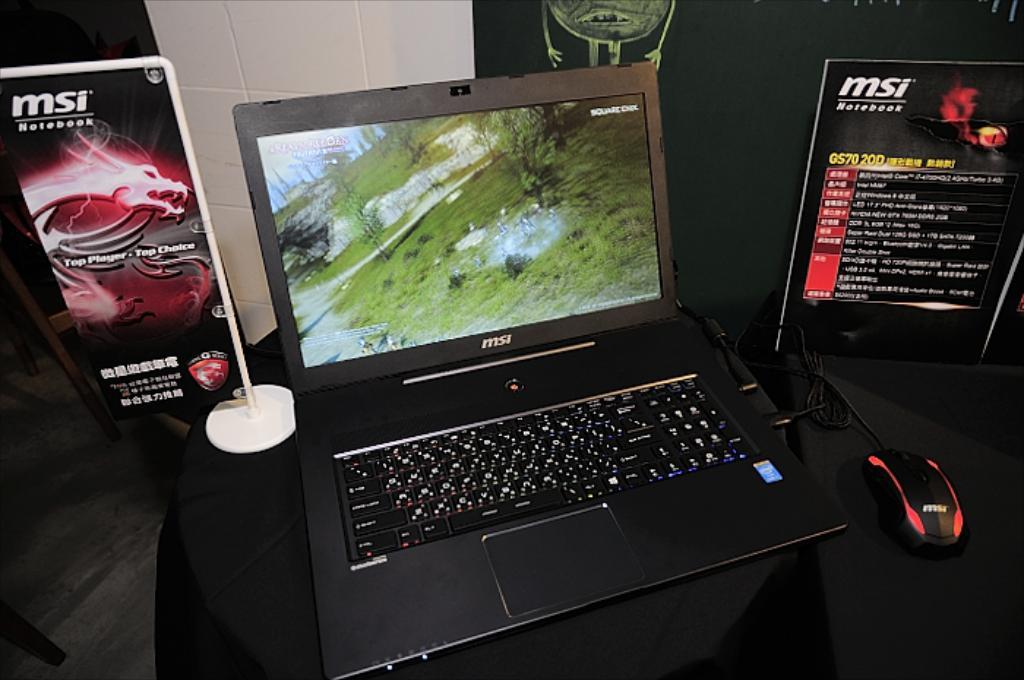<image>
Relay a brief, clear account of the picture shown. A shop display for a MSI branded laptop. 